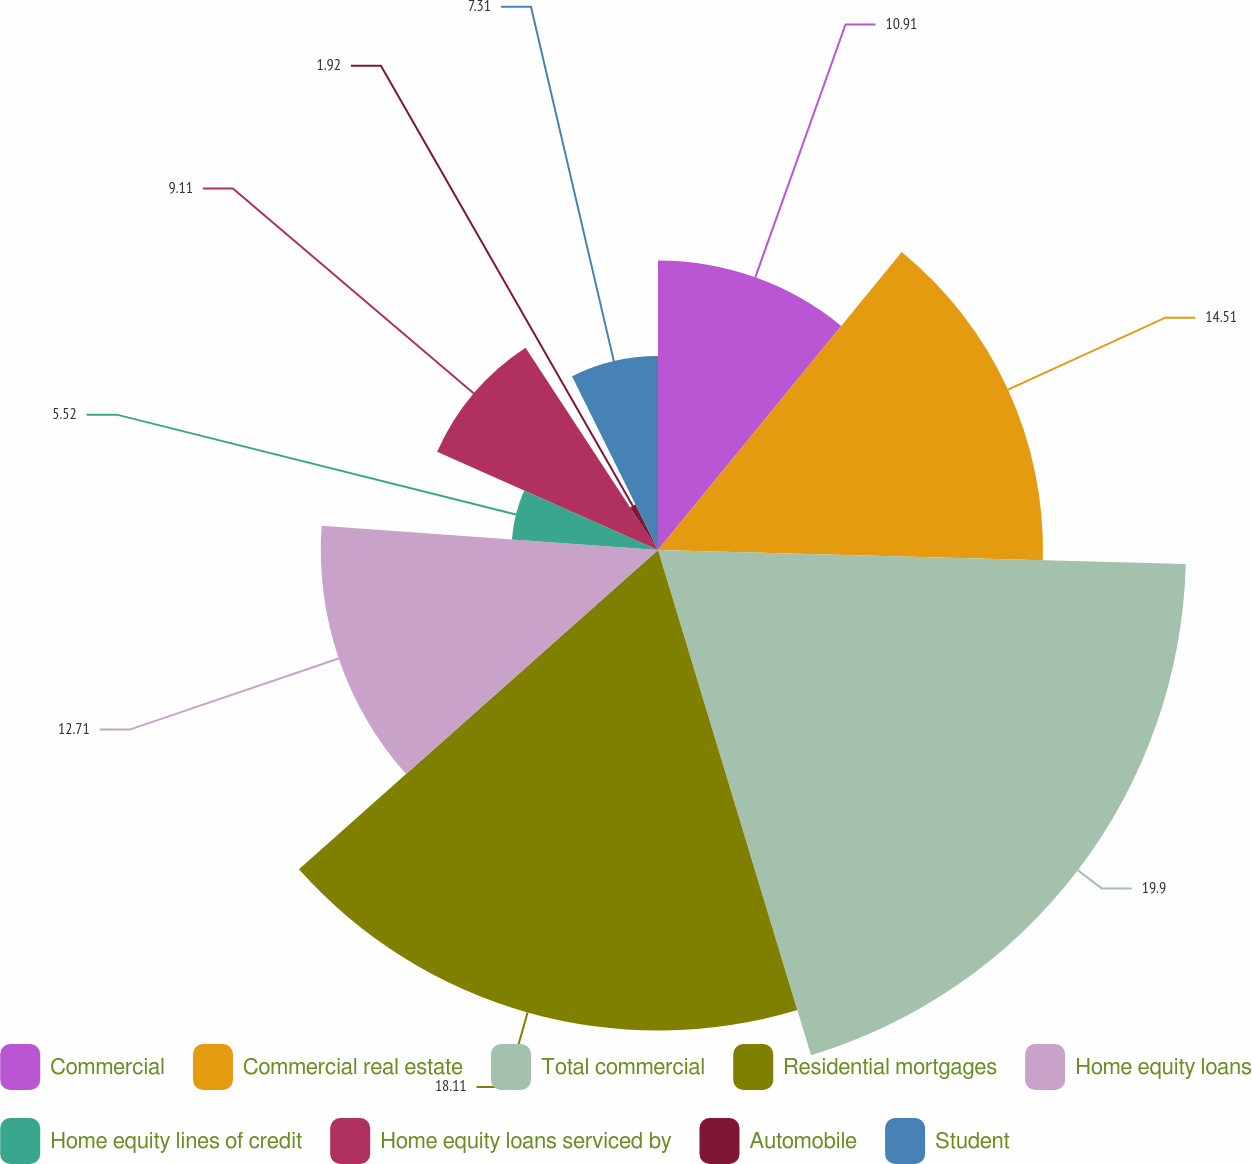Convert chart to OTSL. <chart><loc_0><loc_0><loc_500><loc_500><pie_chart><fcel>Commercial<fcel>Commercial real estate<fcel>Total commercial<fcel>Residential mortgages<fcel>Home equity loans<fcel>Home equity lines of credit<fcel>Home equity loans serviced by<fcel>Automobile<fcel>Student<nl><fcel>10.91%<fcel>14.51%<fcel>19.9%<fcel>18.11%<fcel>12.71%<fcel>5.52%<fcel>9.11%<fcel>1.92%<fcel>7.31%<nl></chart> 